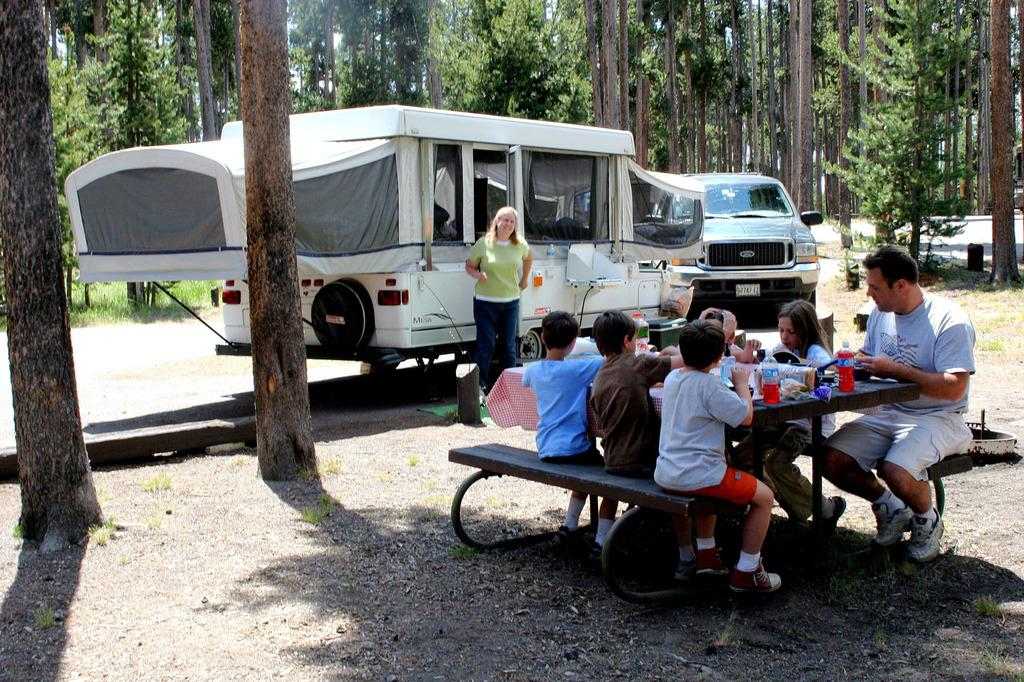What can be seen on the road in the image? There are vehicles parked on the road. What are the people in the image doing? People are seated on a bench. What type of natural elements are present in the image? There are trees around the area. What is the position of the woman in the image? A woman is standing. What type of tray is the squirrel holding in the image? There is no squirrel or tray present in the image. What treatment is the woman receiving in the image? There is no treatment being administered in the image; the woman is simply standing. 